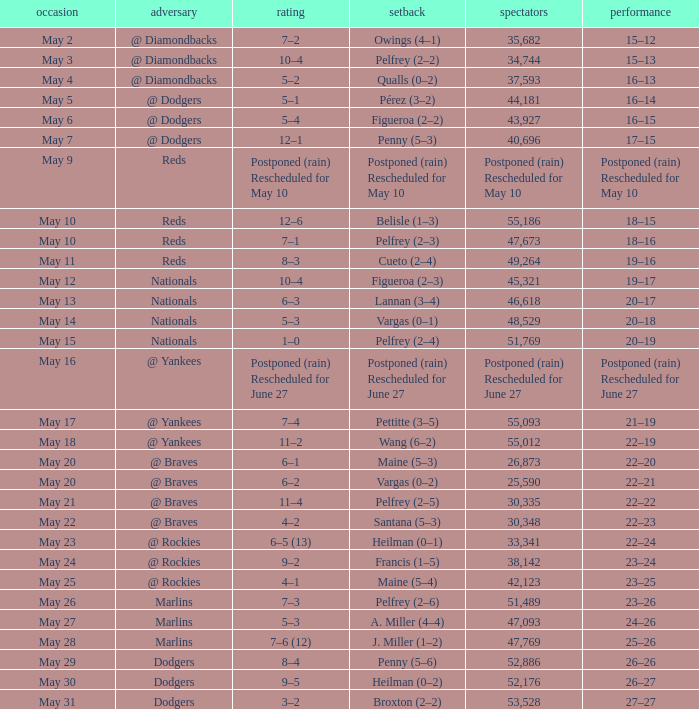Attendance of 30,335 had what record? 22–22. 